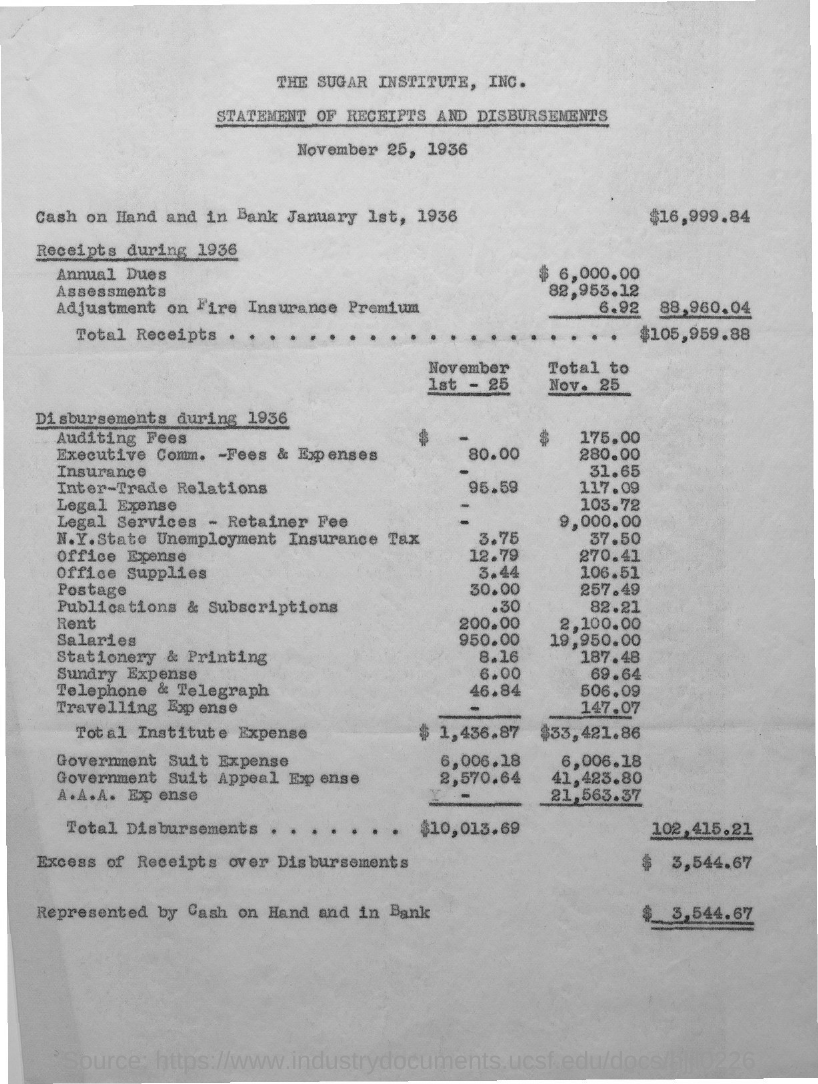What is the title?
Keep it short and to the point. Statement of receipts and disbursements. What is the date mentioned under the title?
Make the answer very short. November 25, 1936. How much is the cash on hand and in bank on January 1st, 1936?
Your response must be concise. $16,999.84. How much is the annual dues?
Offer a very short reply. 6,000.00. How much is the adjustment on fire insurance premium?
Keep it short and to the point. 6.92. How much is the excess of receipts over disbursements?
Give a very brief answer. 3,544.67. 